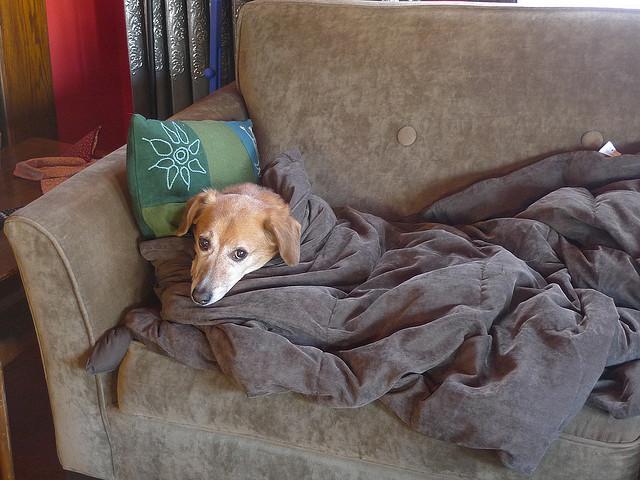IS the dog asleep?
Be succinct. No. What pattern is on the blanket?
Answer briefly. Solid. Where in a house would this photo be taken?
Keep it brief. Living room. What is over the dog?
Answer briefly. Blanket. 